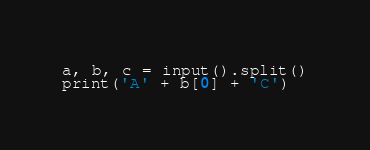Convert code to text. <code><loc_0><loc_0><loc_500><loc_500><_Python_>a, b, c = input().split()
print('A' + b[0] + 'C')</code> 